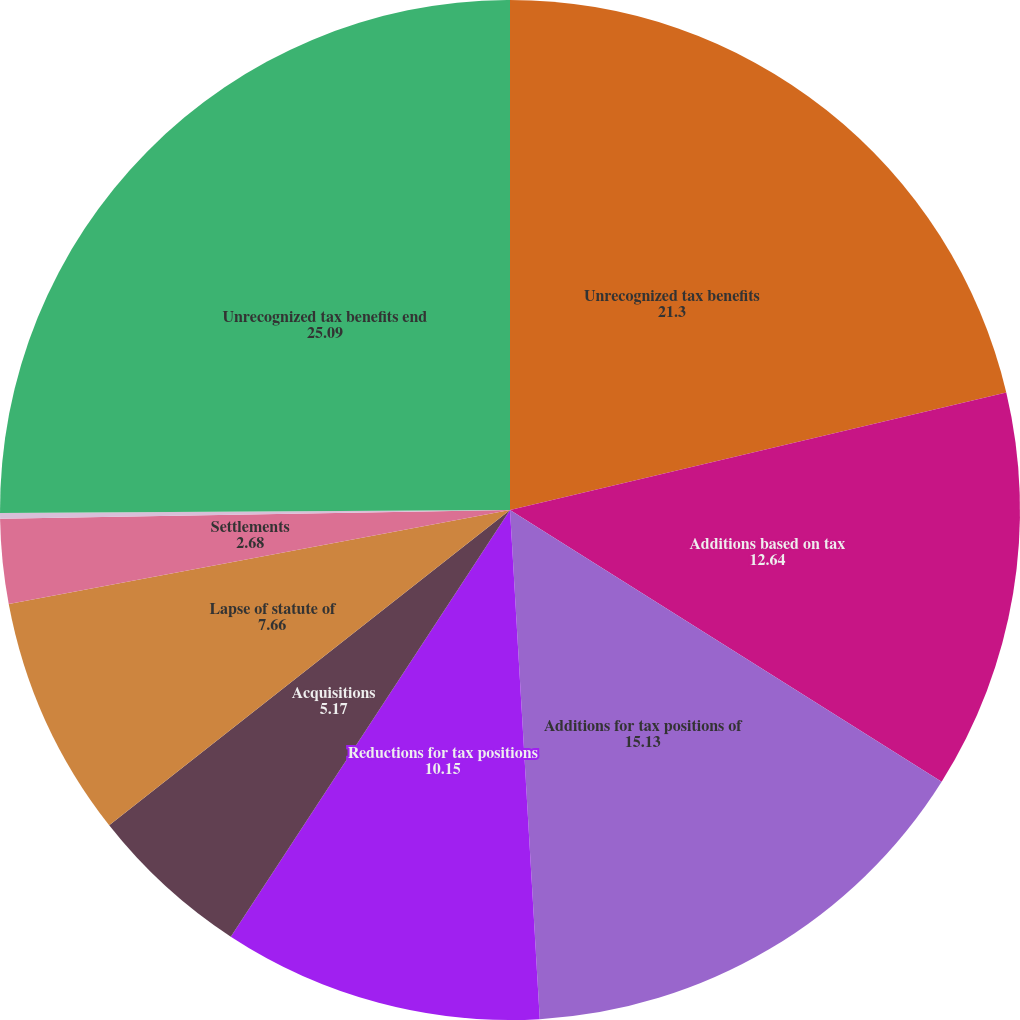<chart> <loc_0><loc_0><loc_500><loc_500><pie_chart><fcel>Unrecognized tax benefits<fcel>Additions based on tax<fcel>Additions for tax positions of<fcel>Reductions for tax positions<fcel>Acquisitions<fcel>Lapse of statute of<fcel>Settlements<fcel>Effect of foreign currency<fcel>Unrecognized tax benefits end<nl><fcel>21.3%<fcel>12.64%<fcel>15.13%<fcel>10.15%<fcel>5.17%<fcel>7.66%<fcel>2.68%<fcel>0.18%<fcel>25.09%<nl></chart> 